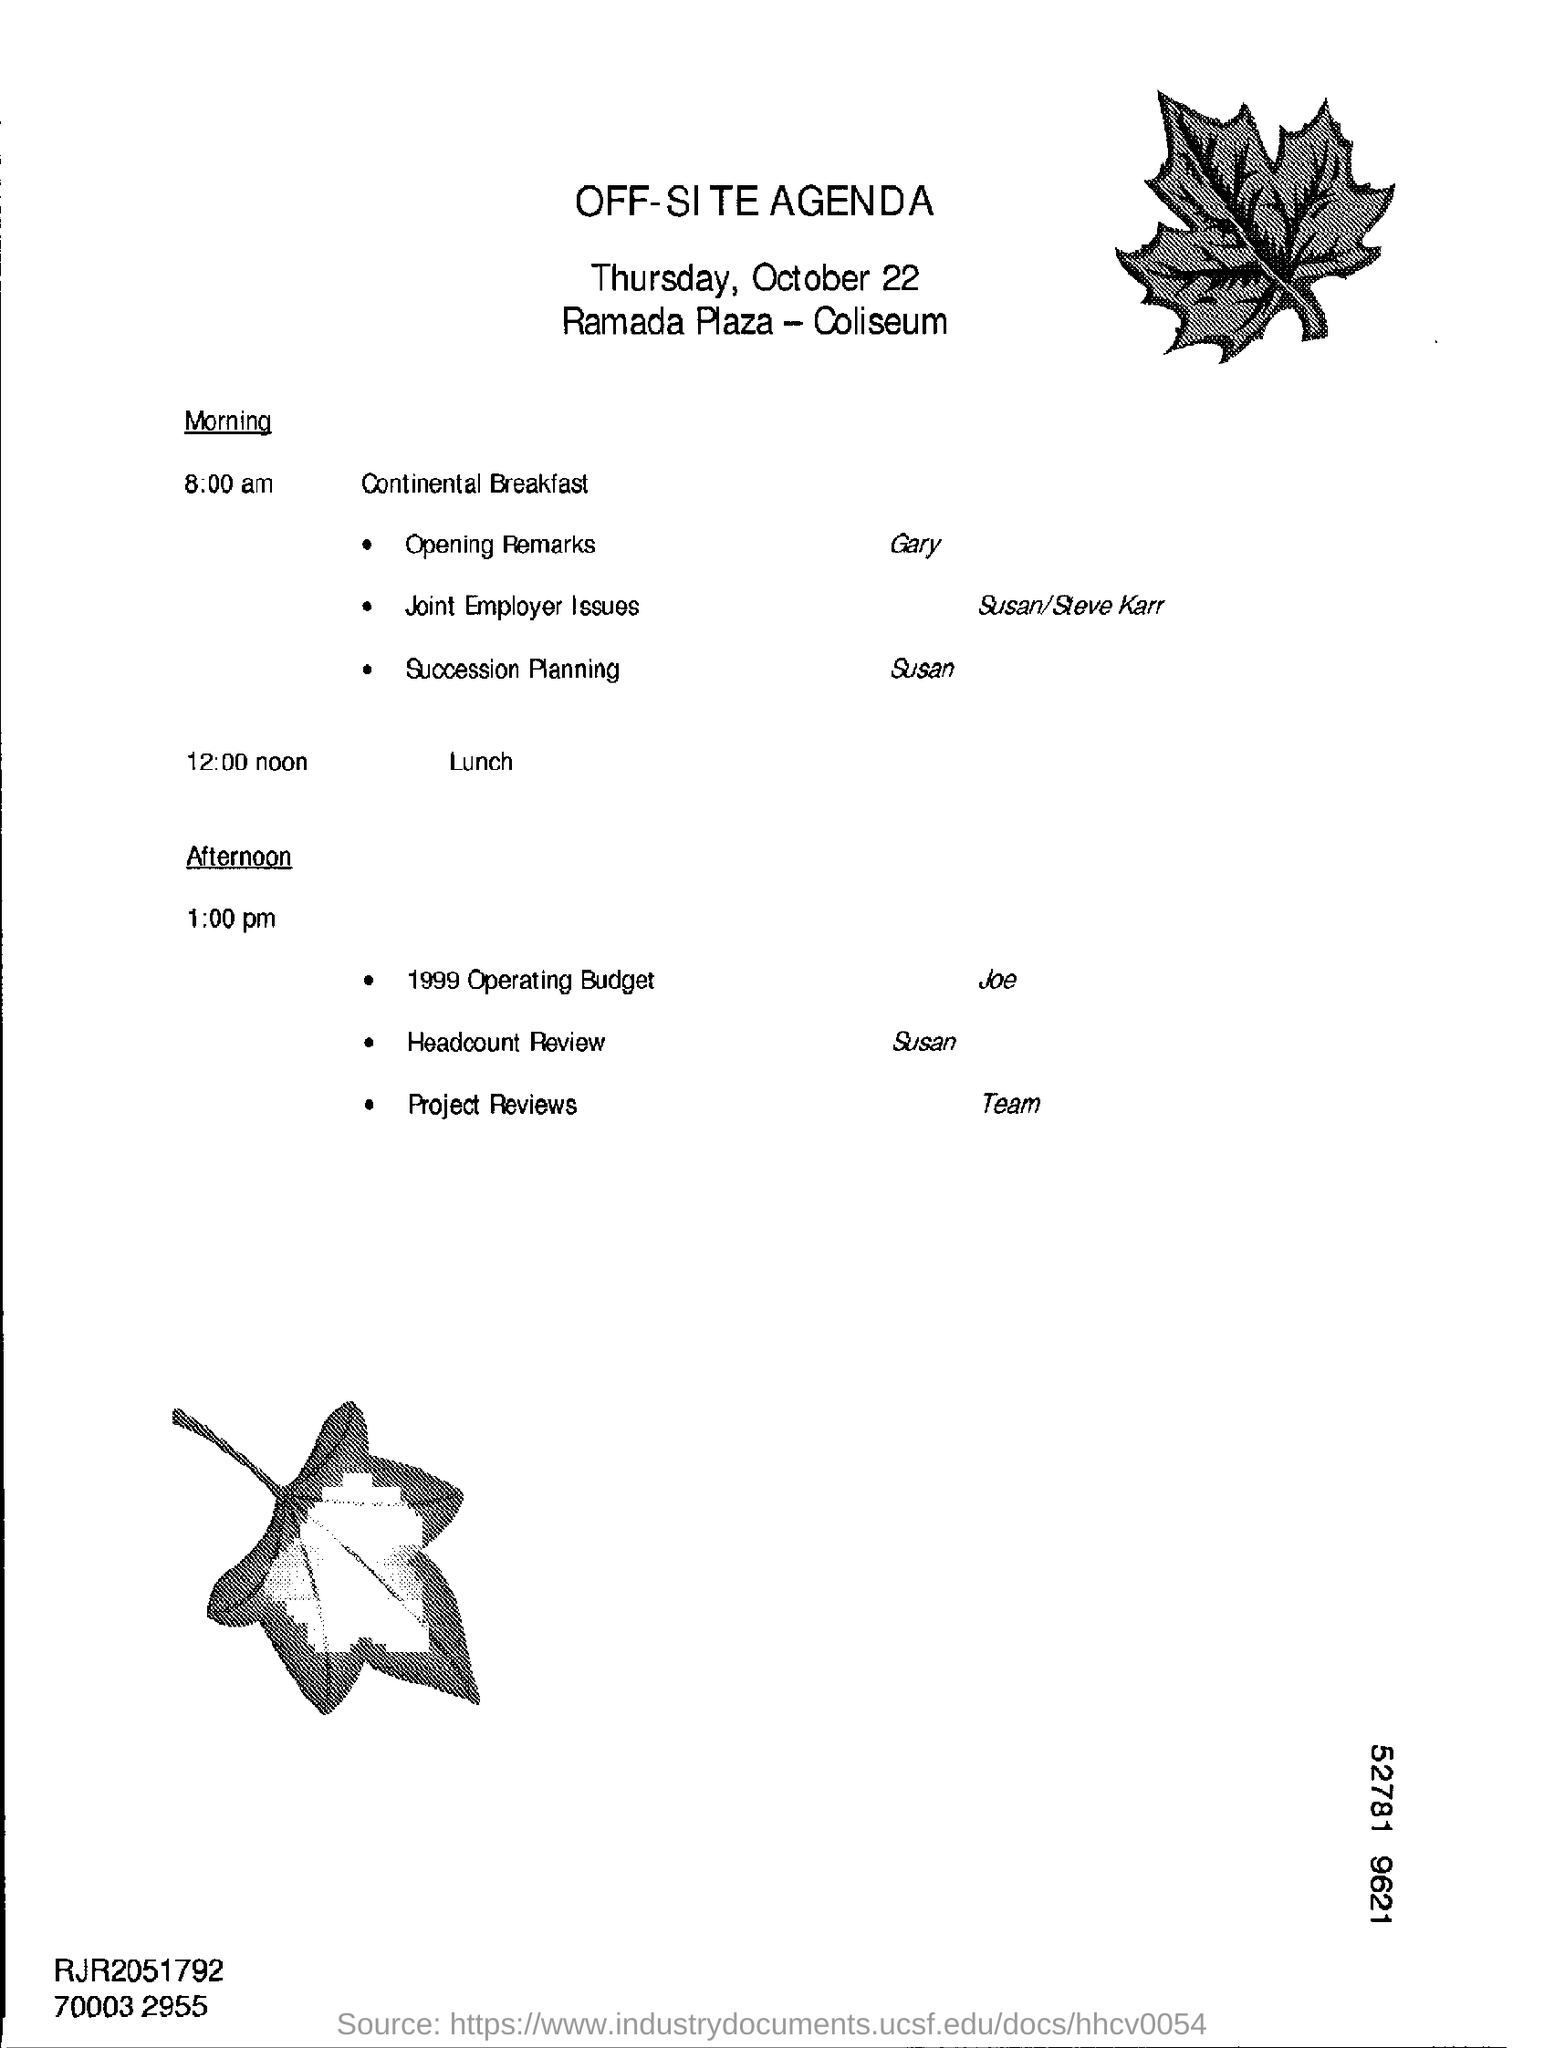Indicate a few pertinent items in this graphic. The title of the document is 'Off-Site Agenda.' The lunch is scheduled for 12:00 noon. The lunch timing is 12:00 noon. 